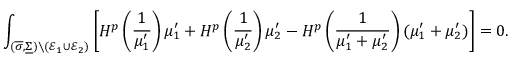Convert formula to latex. <formula><loc_0><loc_0><loc_500><loc_500>\int _ { ( \overline { \sigma } , \underline { \Sigma } ) \ ( \mathcal { E } _ { 1 } \cup \mathcal { E } _ { 2 } ) } \left [ H ^ { p } \left ( \frac { 1 } { \mu _ { 1 } ^ { \prime } } \right ) \mu _ { 1 } ^ { \prime } + H ^ { p } \left ( \frac { 1 } { \mu _ { 2 } ^ { \prime } } \right ) \mu _ { 2 } ^ { \prime } - H ^ { p } \left ( \frac { 1 } { \mu _ { 1 } ^ { \prime } + \mu _ { 2 } ^ { \prime } } \right ) ( \mu _ { 1 } ^ { \prime } + \mu _ { 2 } ^ { \prime } ) \right ] = 0 .</formula> 